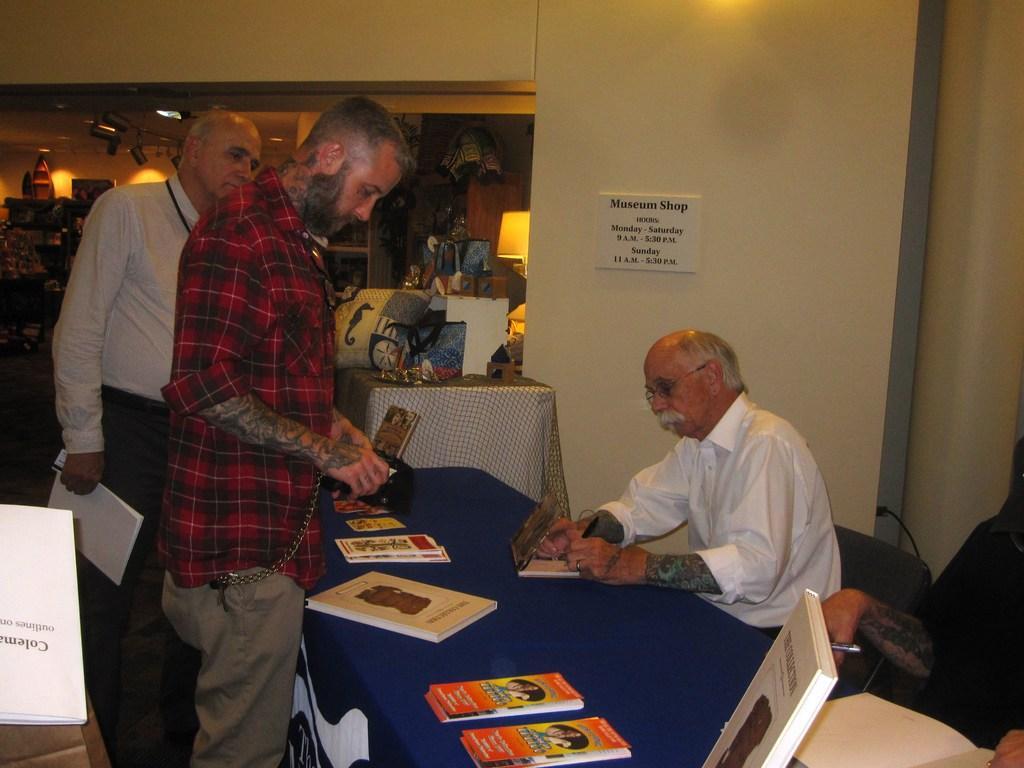In one or two sentences, can you explain what this image depicts? In this picture there are three person. On right there is an old man who is wearing a white shirt , writing something on a book with pen. And he is sitting on a chair. There is a table on which there are pamphlets, book and cloth. On the background we can see a lamp. On this wall there is a poster. On right there is a person who is standing behind the table and holding a white book. 